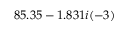<formula> <loc_0><loc_0><loc_500><loc_500>8 5 . 3 5 - 1 . 8 3 1 i ( - 3 )</formula> 